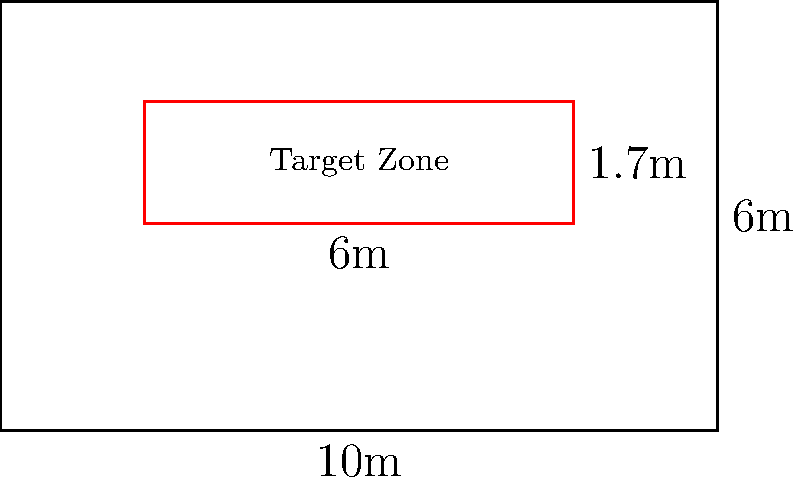In a regulation squash court, the front wall target zone is a rectangular area above the tin. If the front wall is 10m wide and 6m high, and the target zone starts 2.9m from the floor and extends 1.7m upwards, with a width of 6m centered on the wall, what is the area of the target zone in square meters? To find the area of the target zone, we need to follow these steps:

1) Identify the dimensions of the target zone:
   - Width = 6m (given in the question)
   - Height = 1.7m (given in the question)

2) Recall the formula for the area of a rectangle:
   $$ A = w \times h $$
   where $A$ is the area, $w$ is the width, and $h$ is the height.

3) Substitute the values into the formula:
   $$ A = 6m \times 1.7m $$

4) Perform the multiplication:
   $$ A = 10.2m^2 $$

Therefore, the area of the target zone is 10.2 square meters.
Answer: $10.2m^2$ 